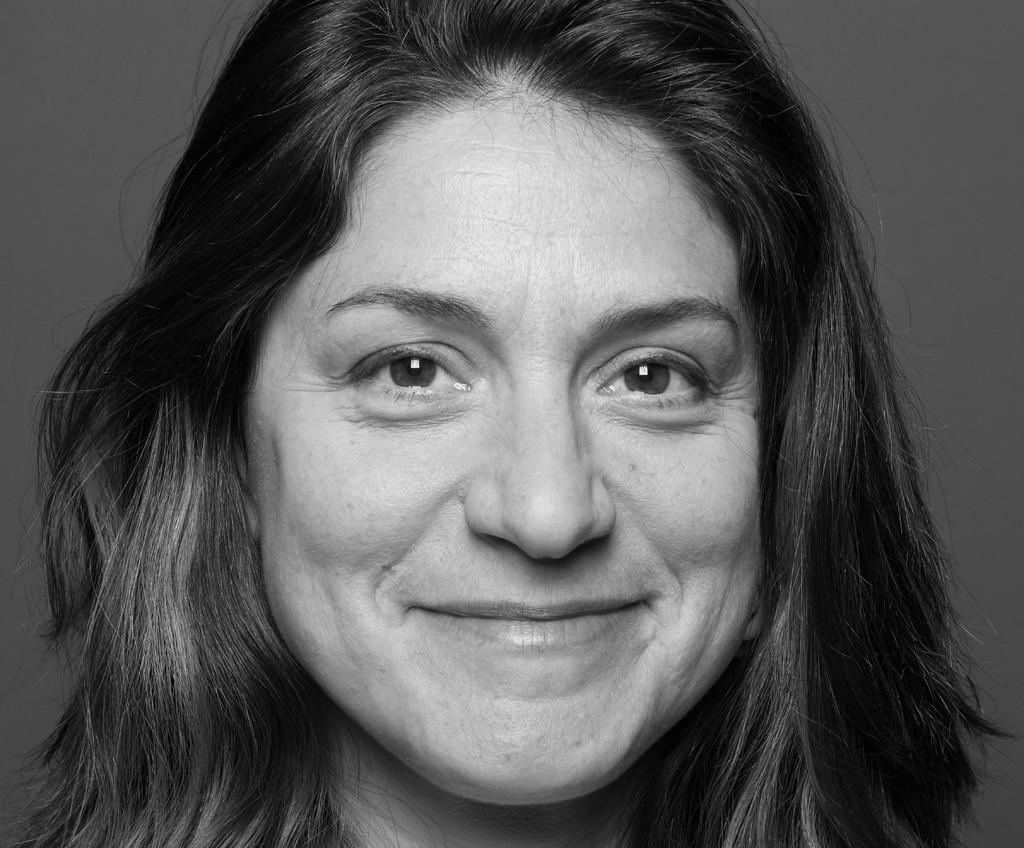What is the main subject of the picture? The main subject of the picture is a woman. Can you describe the woman's facial expression? The woman has a pretty smile on her face. What type of silver object can be seen causing a negative effect on the woman's mood in the image? There is no silver object present in the image, and the woman's mood appears to be positive, as she has a pretty smile on her face. 